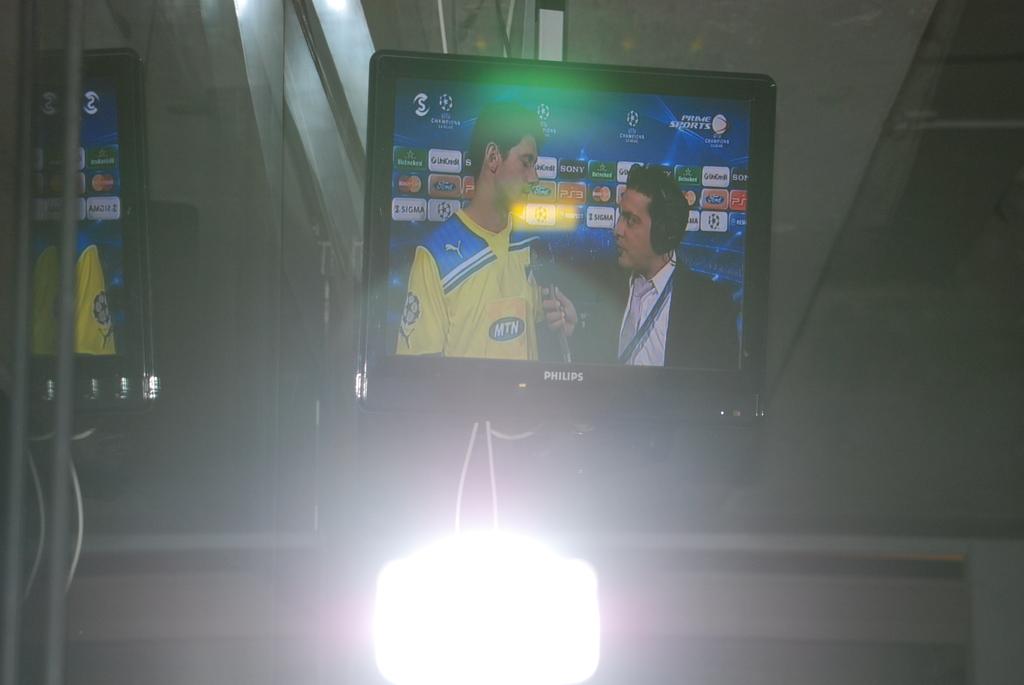What is the television brand name?
Provide a short and direct response. Phillips. Does they player's shirt say mtn on it?
Ensure brevity in your answer.  Yes. 